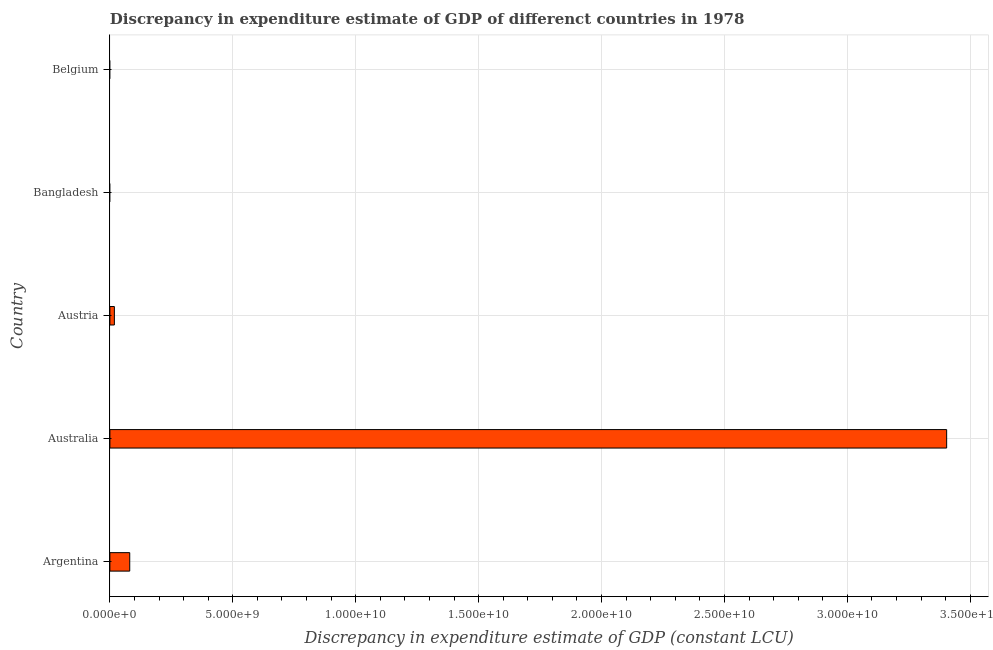Does the graph contain any zero values?
Give a very brief answer. Yes. Does the graph contain grids?
Provide a succinct answer. Yes. What is the title of the graph?
Give a very brief answer. Discrepancy in expenditure estimate of GDP of differenct countries in 1978. What is the label or title of the X-axis?
Offer a terse response. Discrepancy in expenditure estimate of GDP (constant LCU). What is the discrepancy in expenditure estimate of gdp in Austria?
Keep it short and to the point. 1.82e+08. Across all countries, what is the maximum discrepancy in expenditure estimate of gdp?
Your response must be concise. 3.40e+1. In which country was the discrepancy in expenditure estimate of gdp maximum?
Keep it short and to the point. Australia. What is the sum of the discrepancy in expenditure estimate of gdp?
Your answer should be very brief. 3.50e+1. What is the difference between the discrepancy in expenditure estimate of gdp in Argentina and Australia?
Ensure brevity in your answer.  -3.32e+1. What is the average discrepancy in expenditure estimate of gdp per country?
Your answer should be compact. 7.01e+09. What is the median discrepancy in expenditure estimate of gdp?
Your response must be concise. 1.82e+08. Is the discrepancy in expenditure estimate of gdp in Argentina less than that in Austria?
Offer a terse response. No. What is the difference between the highest and the second highest discrepancy in expenditure estimate of gdp?
Your answer should be compact. 3.32e+1. What is the difference between the highest and the lowest discrepancy in expenditure estimate of gdp?
Provide a short and direct response. 3.40e+1. How many bars are there?
Provide a short and direct response. 3. Are the values on the major ticks of X-axis written in scientific E-notation?
Provide a succinct answer. Yes. What is the Discrepancy in expenditure estimate of GDP (constant LCU) of Argentina?
Ensure brevity in your answer.  8.07e+08. What is the Discrepancy in expenditure estimate of GDP (constant LCU) in Australia?
Provide a short and direct response. 3.40e+1. What is the Discrepancy in expenditure estimate of GDP (constant LCU) in Austria?
Offer a very short reply. 1.82e+08. What is the difference between the Discrepancy in expenditure estimate of GDP (constant LCU) in Argentina and Australia?
Offer a terse response. -3.32e+1. What is the difference between the Discrepancy in expenditure estimate of GDP (constant LCU) in Argentina and Austria?
Make the answer very short. 6.25e+08. What is the difference between the Discrepancy in expenditure estimate of GDP (constant LCU) in Australia and Austria?
Give a very brief answer. 3.39e+1. What is the ratio of the Discrepancy in expenditure estimate of GDP (constant LCU) in Argentina to that in Australia?
Your response must be concise. 0.02. What is the ratio of the Discrepancy in expenditure estimate of GDP (constant LCU) in Argentina to that in Austria?
Your answer should be compact. 4.43. What is the ratio of the Discrepancy in expenditure estimate of GDP (constant LCU) in Australia to that in Austria?
Make the answer very short. 186.85. 